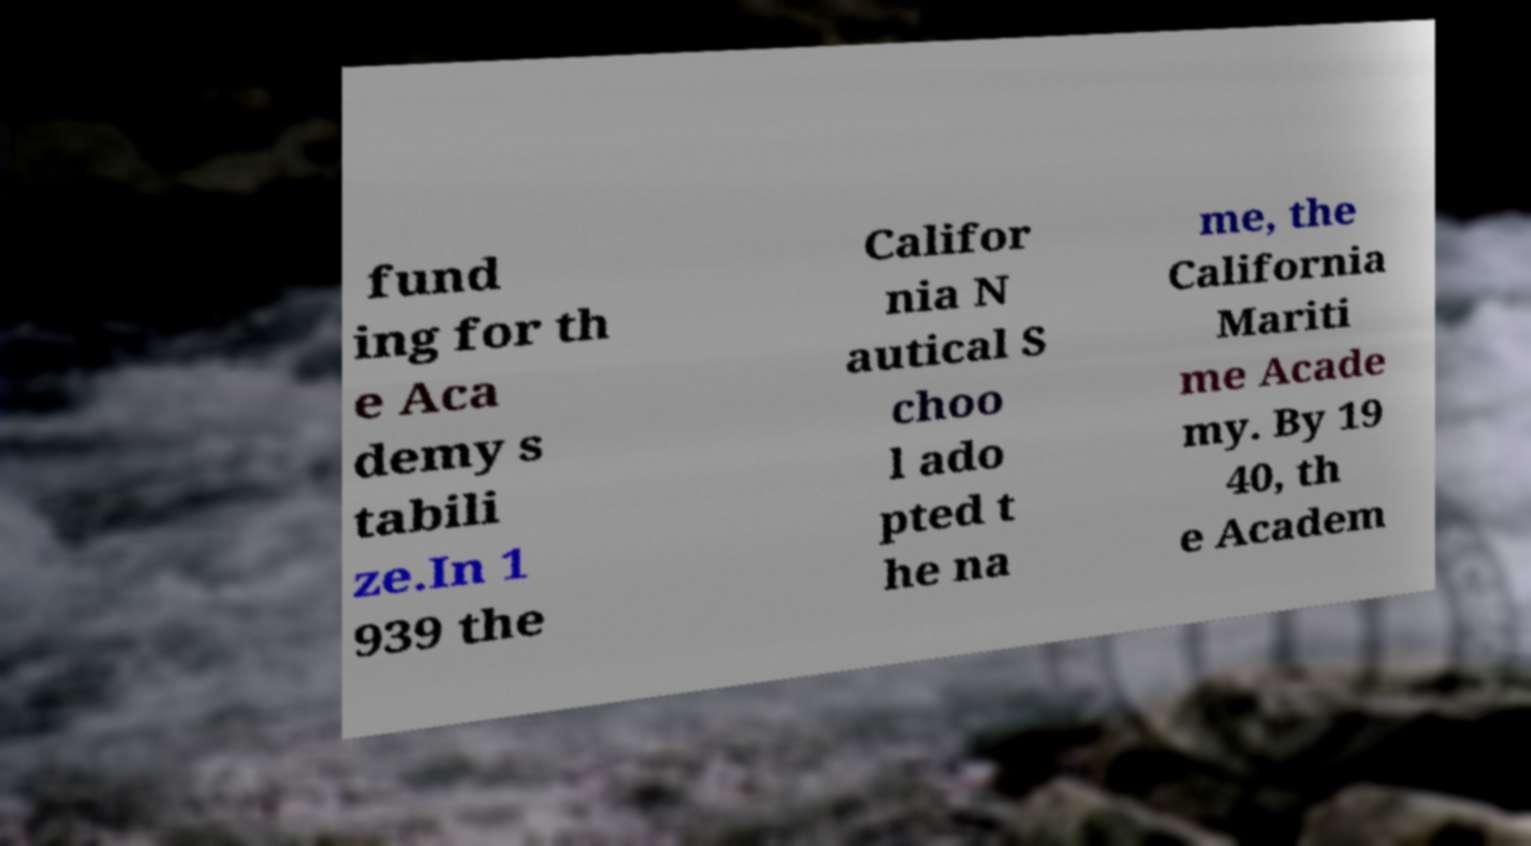For documentation purposes, I need the text within this image transcribed. Could you provide that? fund ing for th e Aca demy s tabili ze.In 1 939 the Califor nia N autical S choo l ado pted t he na me, the California Mariti me Acade my. By 19 40, th e Academ 